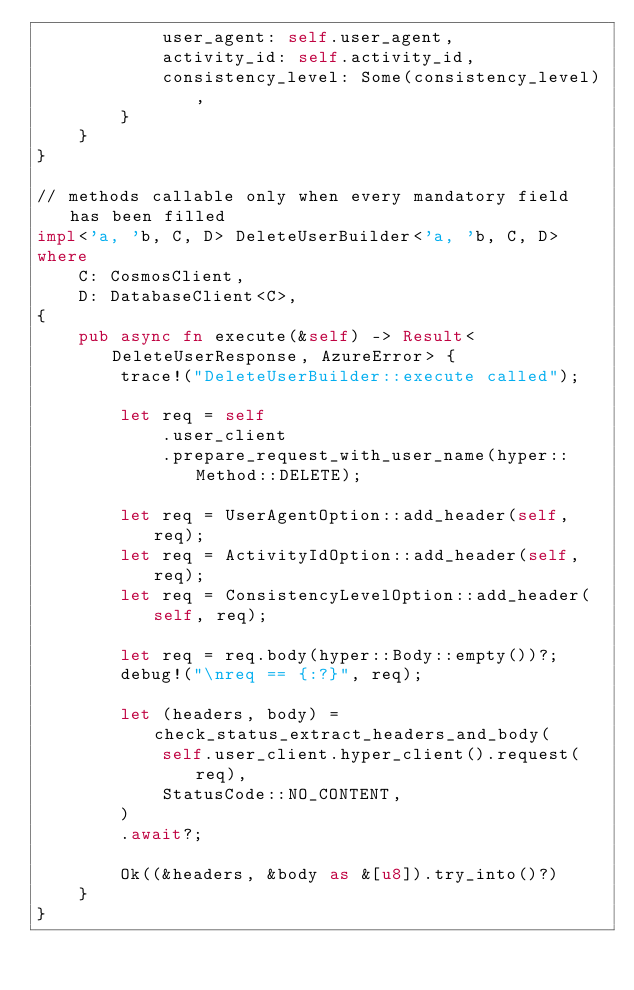<code> <loc_0><loc_0><loc_500><loc_500><_Rust_>            user_agent: self.user_agent,
            activity_id: self.activity_id,
            consistency_level: Some(consistency_level),
        }
    }
}

// methods callable only when every mandatory field has been filled
impl<'a, 'b, C, D> DeleteUserBuilder<'a, 'b, C, D>
where
    C: CosmosClient,
    D: DatabaseClient<C>,
{
    pub async fn execute(&self) -> Result<DeleteUserResponse, AzureError> {
        trace!("DeleteUserBuilder::execute called");

        let req = self
            .user_client
            .prepare_request_with_user_name(hyper::Method::DELETE);

        let req = UserAgentOption::add_header(self, req);
        let req = ActivityIdOption::add_header(self, req);
        let req = ConsistencyLevelOption::add_header(self, req);

        let req = req.body(hyper::Body::empty())?;
        debug!("\nreq == {:?}", req);

        let (headers, body) = check_status_extract_headers_and_body(
            self.user_client.hyper_client().request(req),
            StatusCode::NO_CONTENT,
        )
        .await?;

        Ok((&headers, &body as &[u8]).try_into()?)
    }
}
</code> 